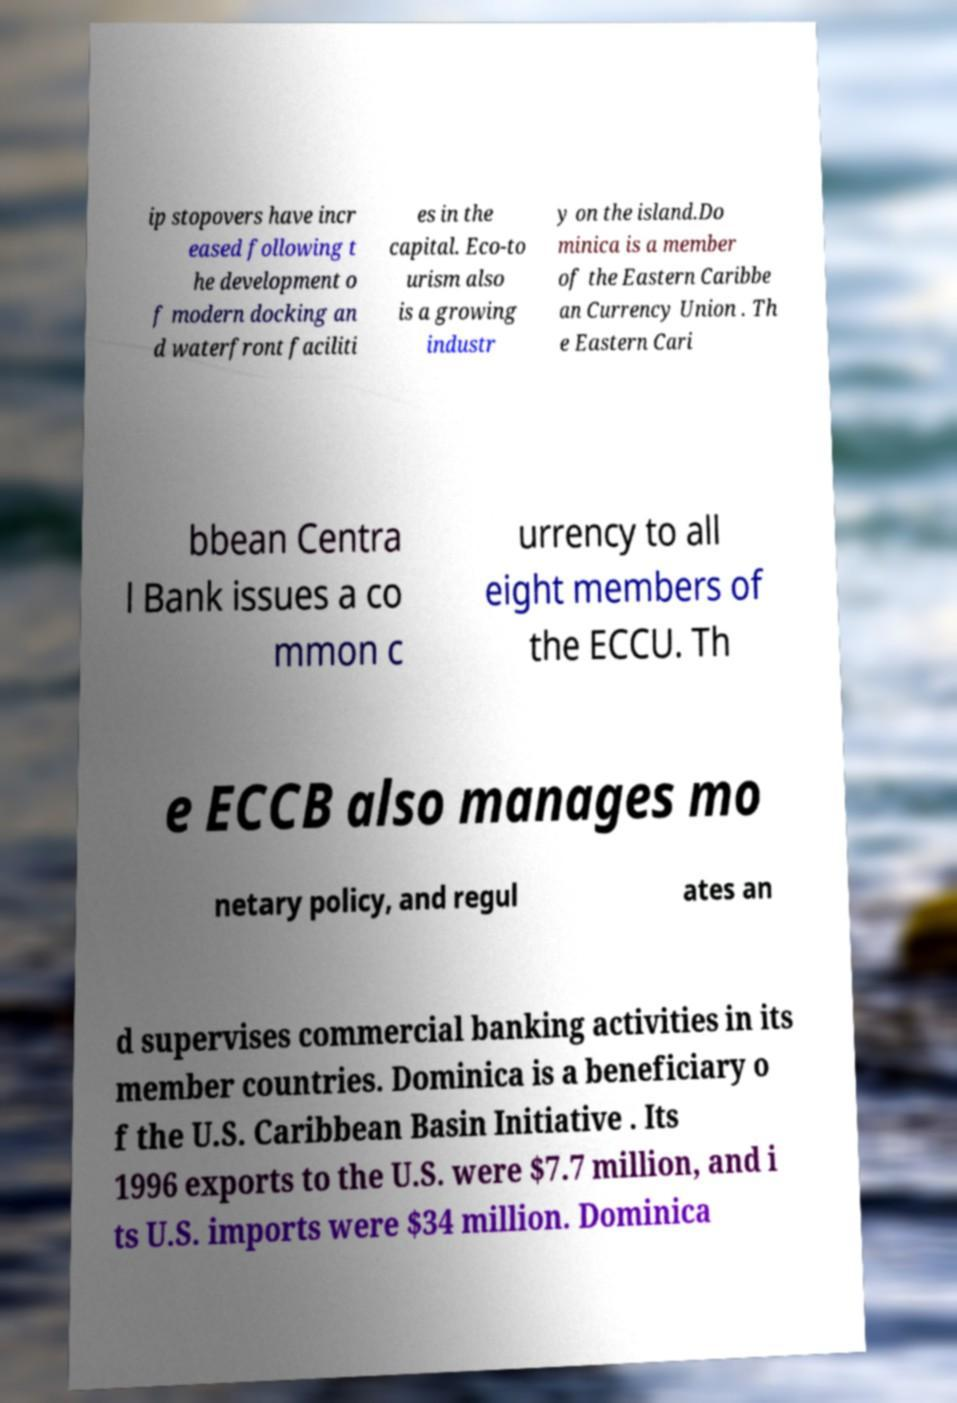For documentation purposes, I need the text within this image transcribed. Could you provide that? ip stopovers have incr eased following t he development o f modern docking an d waterfront faciliti es in the capital. Eco-to urism also is a growing industr y on the island.Do minica is a member of the Eastern Caribbe an Currency Union . Th e Eastern Cari bbean Centra l Bank issues a co mmon c urrency to all eight members of the ECCU. Th e ECCB also manages mo netary policy, and regul ates an d supervises commercial banking activities in its member countries. Dominica is a beneficiary o f the U.S. Caribbean Basin Initiative . Its 1996 exports to the U.S. were $7.7 million, and i ts U.S. imports were $34 million. Dominica 